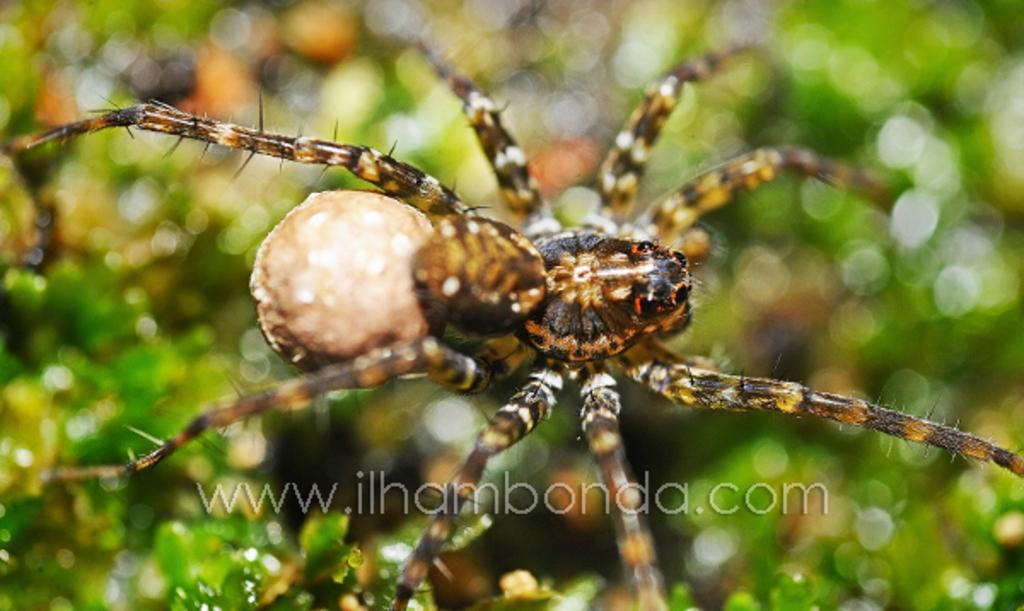What is the main subject of the image? There is a spider in the image. Can you describe the appearance of the spider? The spider is brown in color. What can be seen in the background of the image? There are leaves in the background of the image. What type of juice is being squeezed out of the spider in the image? There is no juice being squeezed out of the spider in the image, as it is a photograph of a spider and not a scene involving juice. 